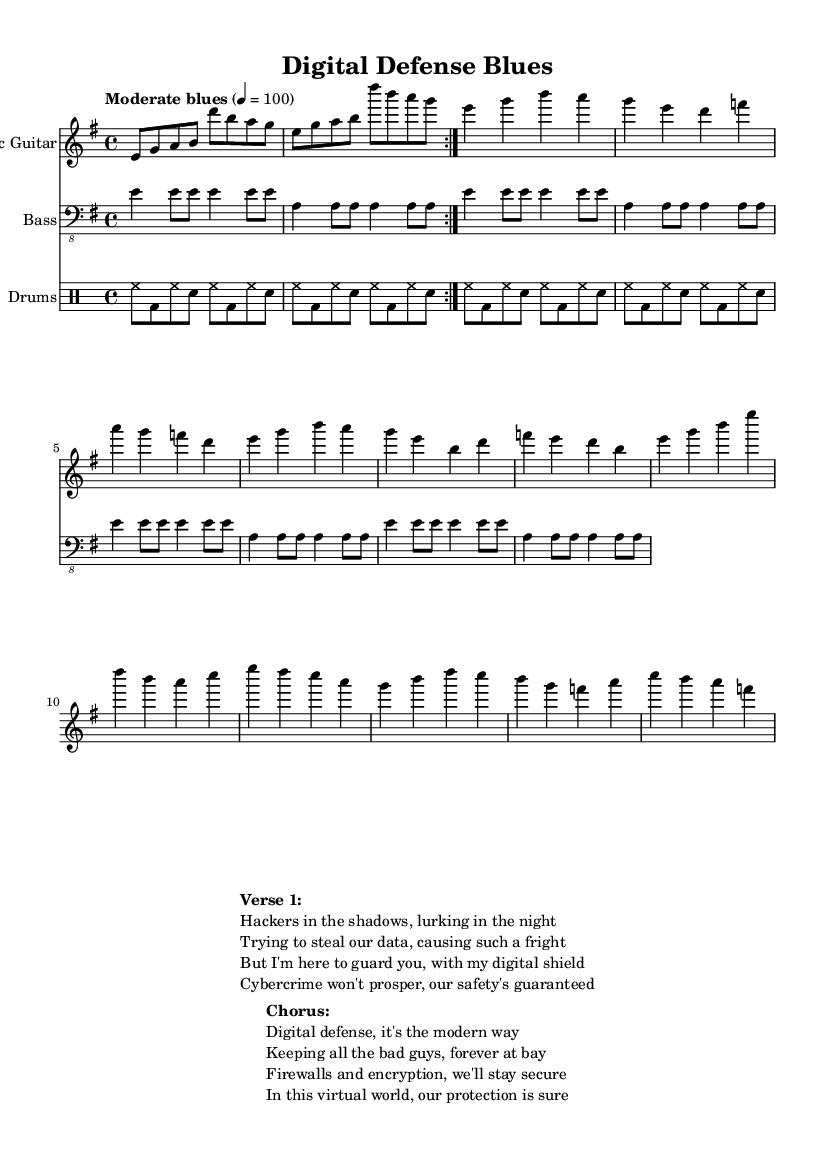What is the key signature of this music? The key signature indicates that the piece is in E minor, which has one sharp (F#). This can be determined by looking for the key signature symbol at the beginning of the staff.
Answer: E minor What is the time signature of this music? The time signature at the beginning of the score shows 4/4, which means there are four beats in each measure and a quarter note gets one beat. This is clearly indicated near the beginning of the sheet.
Answer: 4/4 What is the tempo marking for this piece? The tempo marking is "Moderate blues" followed by a BPM marking of 100, which indicates the speed of the music. This information helps to understand the pace at which the piece should be played.
Answer: Moderate blues, 100 How many measures does the electric guitar part repeat? In the electric guitar part, there is a repeat sign which indicates the section that is played twice. Thus, after analyzing the part and noting the repeat symbol, we can conclude that it is two measures of music that repeat.
Answer: 2 What are the main themes present in the lyrics? The lyrics describe themes of cybercrime and digital defense, emphasizing the idea of protection against hackers and the importance of cybersecurity. By examining the 'Verse 1' and 'Chorus' sections, these themes become clear in the context of today's digital world.
Answer: Cybercrime, digital defense What types of instruments are included in this score? The score notation shows three different staves. The first staff for the electric guitar, the second staff for the bass guitar (with a bass clef indication), and the third staff labeled for drums. By identifying the instrument names above each staff, we can easily summarize the instrumentation involved.
Answer: Electric guitar, bass guitar, drums What is the role of firewalls mentioned in the lyrics? In the lyrics, firewalls are referenced as part of the digital defense strategy, serving as barriers to protect against unauthorized access. This implies an understanding of digital security and the importance of implementing protective measures in cyber environments.
Answer: Protective barriers 